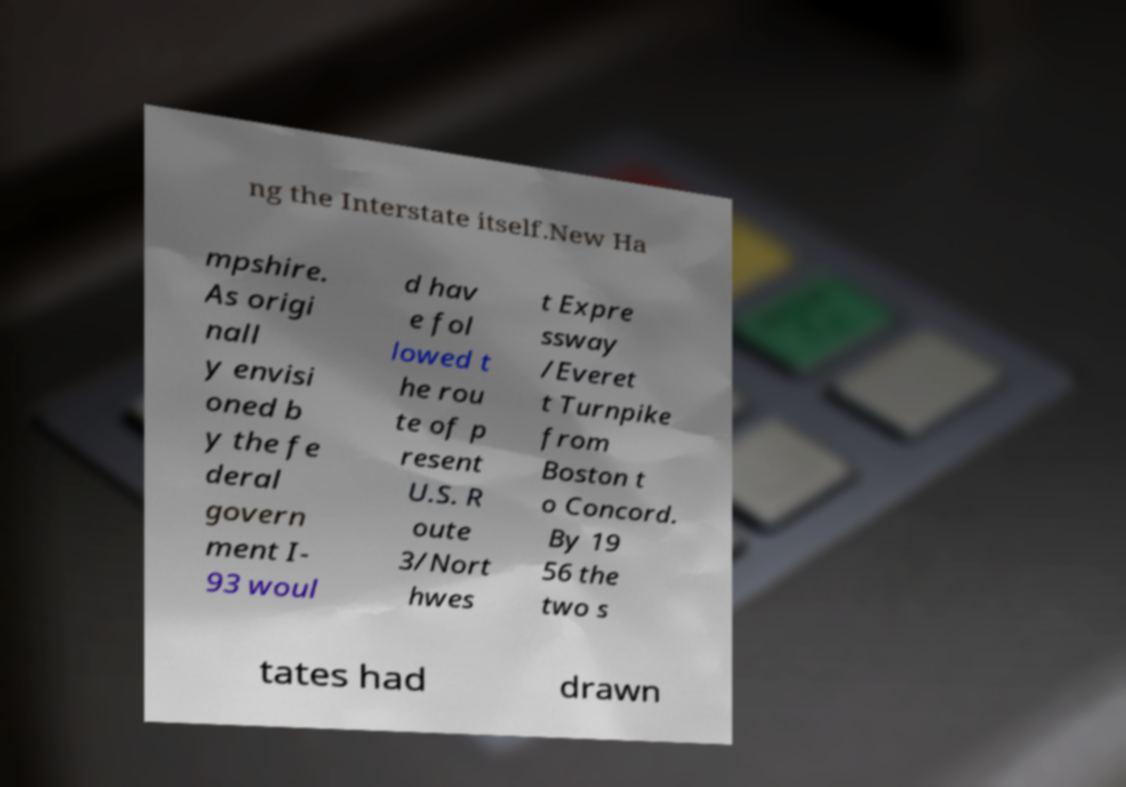Can you accurately transcribe the text from the provided image for me? ng the Interstate itself.New Ha mpshire. As origi nall y envisi oned b y the fe deral govern ment I- 93 woul d hav e fol lowed t he rou te of p resent U.S. R oute 3/Nort hwes t Expre ssway /Everet t Turnpike from Boston t o Concord. By 19 56 the two s tates had drawn 